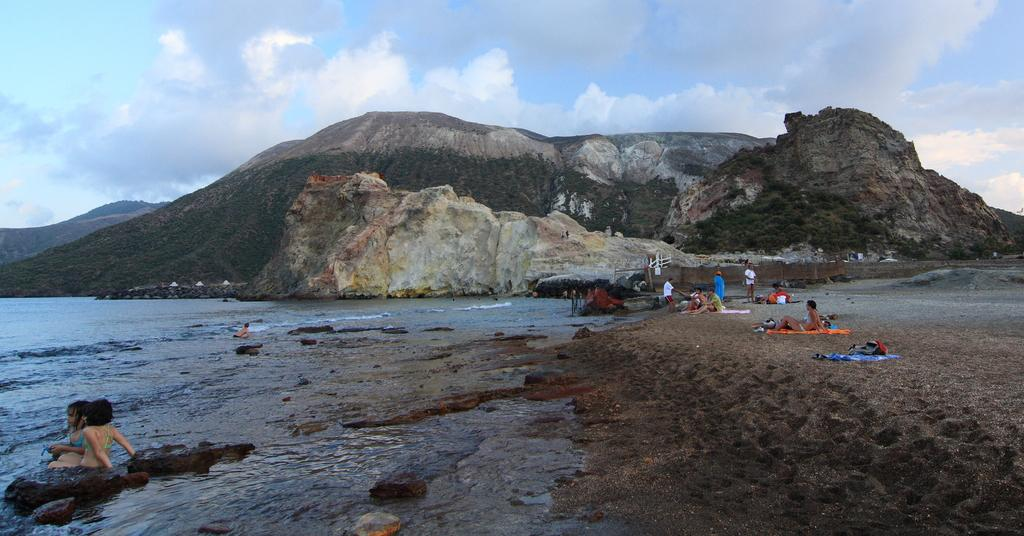What type of natural formation can be seen in the background of the image? There are mountains in the background of the image. What else is visible in the background of the image? The sky and clouds are present in the background of the image. What is located at the bottom of the image? There is water at the bottom of the image. What are the people in the image doing? People are sitting on the sea shore. What type of stick can be seen making noise in the image? There is no stick or noise present in the image. Is there a birthday celebration happening in the image? There is no indication of a birthday celebration in the image. 